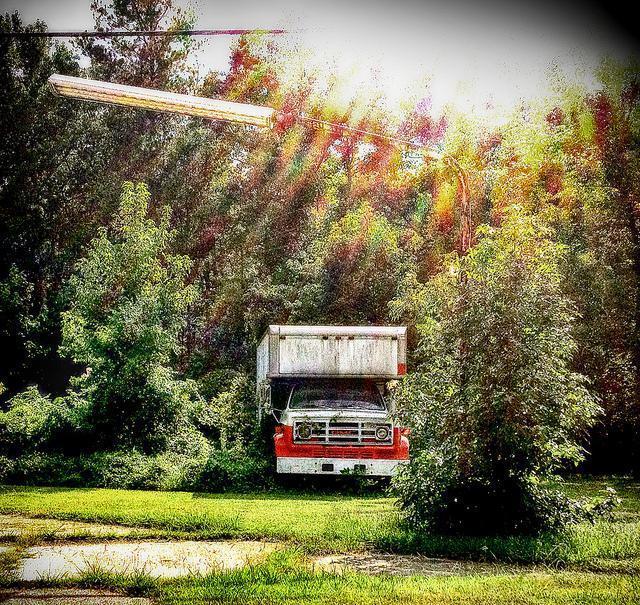How many planes have orange tail sections?
Give a very brief answer. 0. 